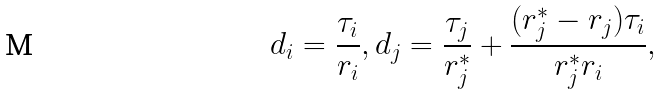<formula> <loc_0><loc_0><loc_500><loc_500>d _ { i } = \frac { \tau _ { i } } { r _ { i } } , d _ { j } = \frac { \tau _ { j } } { r _ { j } ^ { * } } + \frac { ( r _ { j } ^ { * } - r _ { j } ) \tau _ { i } } { r _ { j } ^ { * } r _ { i } } ,</formula> 